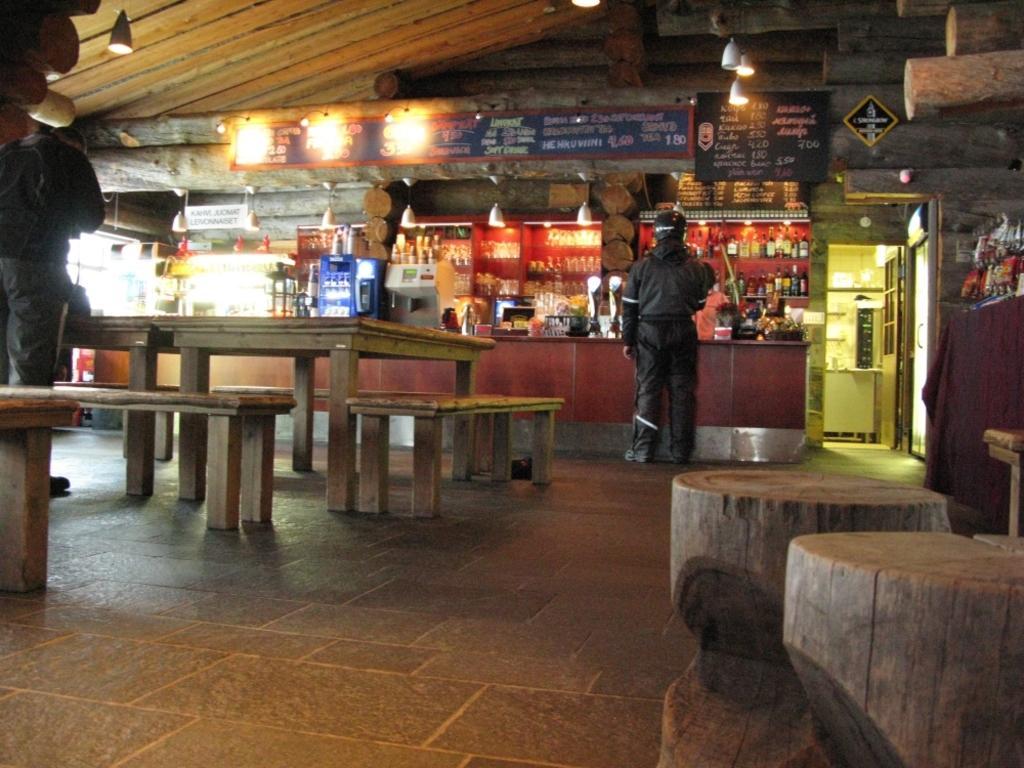How would you summarize this image in a sentence or two? In this image I can see few people are standing and also I can see few benches and tables. 